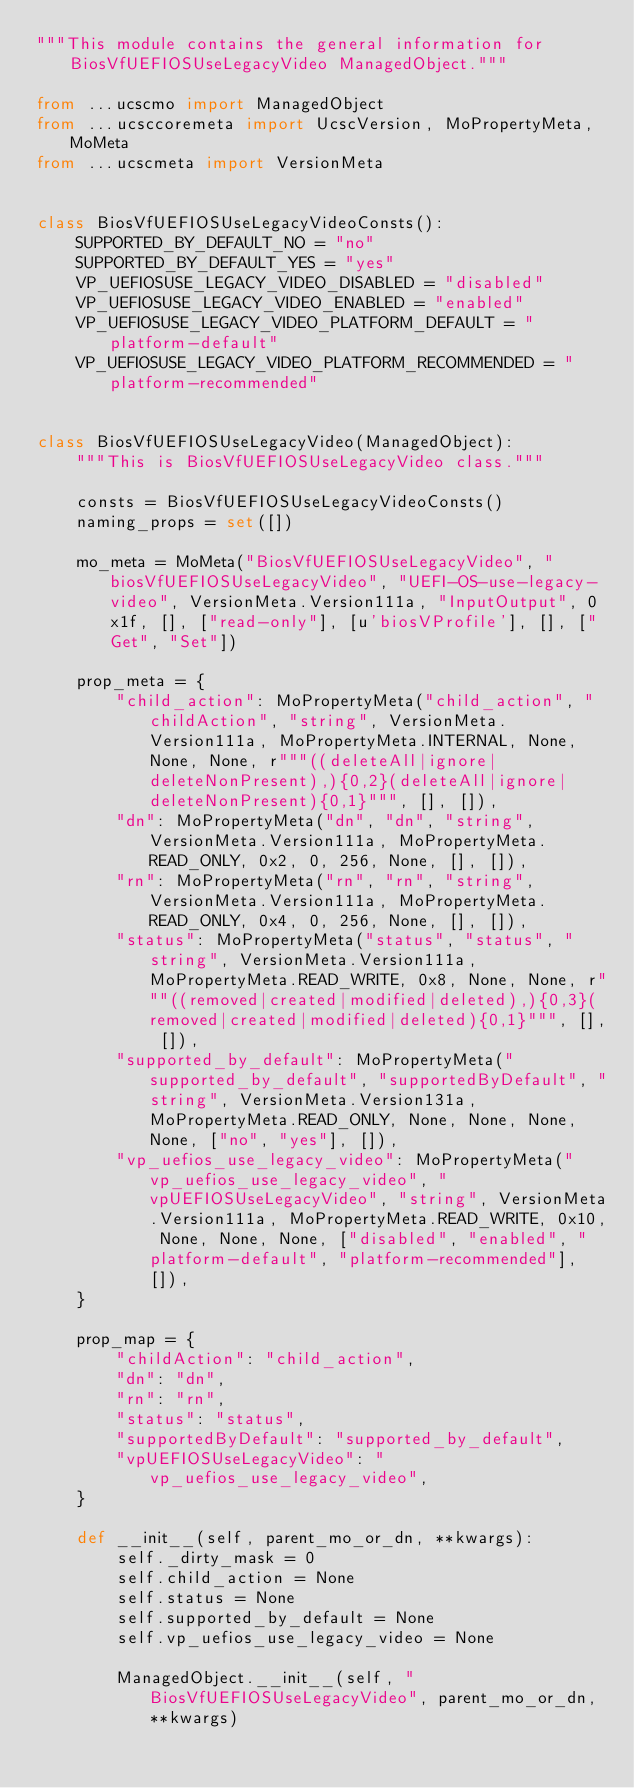<code> <loc_0><loc_0><loc_500><loc_500><_Python_>"""This module contains the general information for BiosVfUEFIOSUseLegacyVideo ManagedObject."""

from ...ucscmo import ManagedObject
from ...ucsccoremeta import UcscVersion, MoPropertyMeta, MoMeta
from ...ucscmeta import VersionMeta


class BiosVfUEFIOSUseLegacyVideoConsts():
    SUPPORTED_BY_DEFAULT_NO = "no"
    SUPPORTED_BY_DEFAULT_YES = "yes"
    VP_UEFIOSUSE_LEGACY_VIDEO_DISABLED = "disabled"
    VP_UEFIOSUSE_LEGACY_VIDEO_ENABLED = "enabled"
    VP_UEFIOSUSE_LEGACY_VIDEO_PLATFORM_DEFAULT = "platform-default"
    VP_UEFIOSUSE_LEGACY_VIDEO_PLATFORM_RECOMMENDED = "platform-recommended"


class BiosVfUEFIOSUseLegacyVideo(ManagedObject):
    """This is BiosVfUEFIOSUseLegacyVideo class."""

    consts = BiosVfUEFIOSUseLegacyVideoConsts()
    naming_props = set([])

    mo_meta = MoMeta("BiosVfUEFIOSUseLegacyVideo", "biosVfUEFIOSUseLegacyVideo", "UEFI-OS-use-legacy-video", VersionMeta.Version111a, "InputOutput", 0x1f, [], ["read-only"], [u'biosVProfile'], [], ["Get", "Set"])

    prop_meta = {
        "child_action": MoPropertyMeta("child_action", "childAction", "string", VersionMeta.Version111a, MoPropertyMeta.INTERNAL, None, None, None, r"""((deleteAll|ignore|deleteNonPresent),){0,2}(deleteAll|ignore|deleteNonPresent){0,1}""", [], []), 
        "dn": MoPropertyMeta("dn", "dn", "string", VersionMeta.Version111a, MoPropertyMeta.READ_ONLY, 0x2, 0, 256, None, [], []), 
        "rn": MoPropertyMeta("rn", "rn", "string", VersionMeta.Version111a, MoPropertyMeta.READ_ONLY, 0x4, 0, 256, None, [], []), 
        "status": MoPropertyMeta("status", "status", "string", VersionMeta.Version111a, MoPropertyMeta.READ_WRITE, 0x8, None, None, r"""((removed|created|modified|deleted),){0,3}(removed|created|modified|deleted){0,1}""", [], []), 
        "supported_by_default": MoPropertyMeta("supported_by_default", "supportedByDefault", "string", VersionMeta.Version131a, MoPropertyMeta.READ_ONLY, None, None, None, None, ["no", "yes"], []), 
        "vp_uefios_use_legacy_video": MoPropertyMeta("vp_uefios_use_legacy_video", "vpUEFIOSUseLegacyVideo", "string", VersionMeta.Version111a, MoPropertyMeta.READ_WRITE, 0x10, None, None, None, ["disabled", "enabled", "platform-default", "platform-recommended"], []), 
    }

    prop_map = {
        "childAction": "child_action", 
        "dn": "dn", 
        "rn": "rn", 
        "status": "status", 
        "supportedByDefault": "supported_by_default", 
        "vpUEFIOSUseLegacyVideo": "vp_uefios_use_legacy_video", 
    }

    def __init__(self, parent_mo_or_dn, **kwargs):
        self._dirty_mask = 0
        self.child_action = None
        self.status = None
        self.supported_by_default = None
        self.vp_uefios_use_legacy_video = None

        ManagedObject.__init__(self, "BiosVfUEFIOSUseLegacyVideo", parent_mo_or_dn, **kwargs)

</code> 